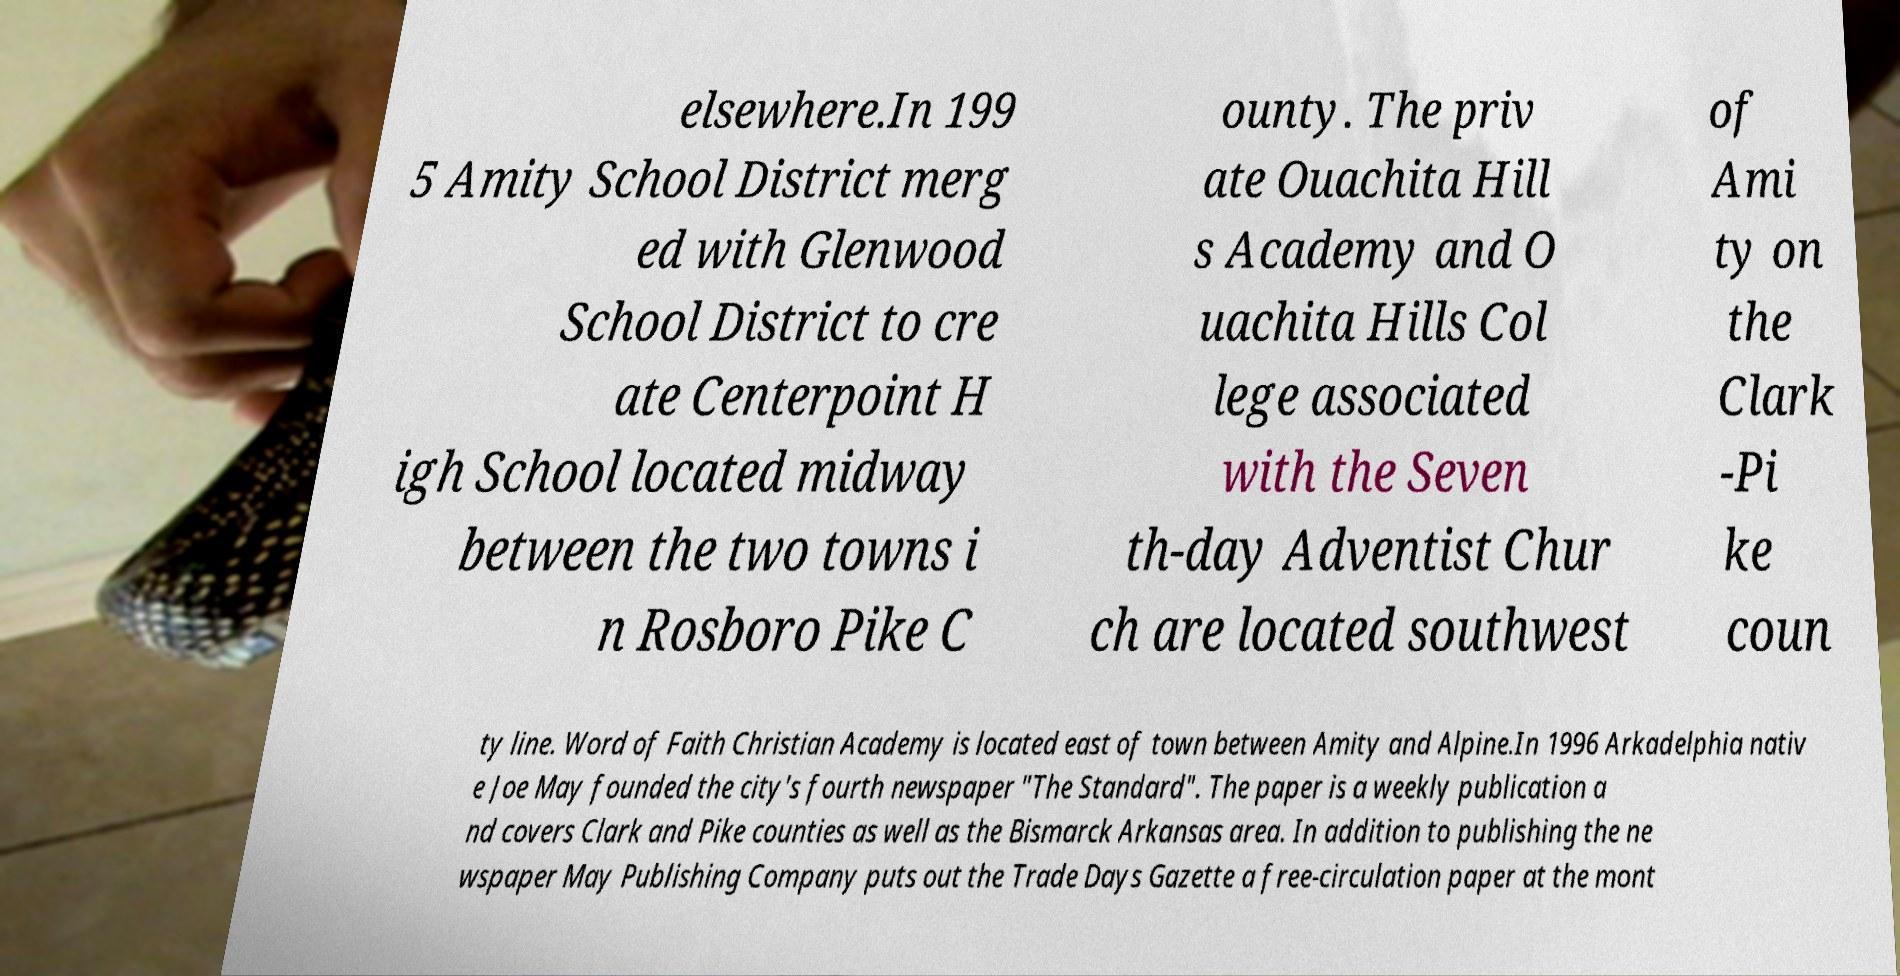Please read and relay the text visible in this image. What does it say? elsewhere.In 199 5 Amity School District merg ed with Glenwood School District to cre ate Centerpoint H igh School located midway between the two towns i n Rosboro Pike C ounty. The priv ate Ouachita Hill s Academy and O uachita Hills Col lege associated with the Seven th-day Adventist Chur ch are located southwest of Ami ty on the Clark -Pi ke coun ty line. Word of Faith Christian Academy is located east of town between Amity and Alpine.In 1996 Arkadelphia nativ e Joe May founded the city's fourth newspaper "The Standard". The paper is a weekly publication a nd covers Clark and Pike counties as well as the Bismarck Arkansas area. In addition to publishing the ne wspaper May Publishing Company puts out the Trade Days Gazette a free-circulation paper at the mont 